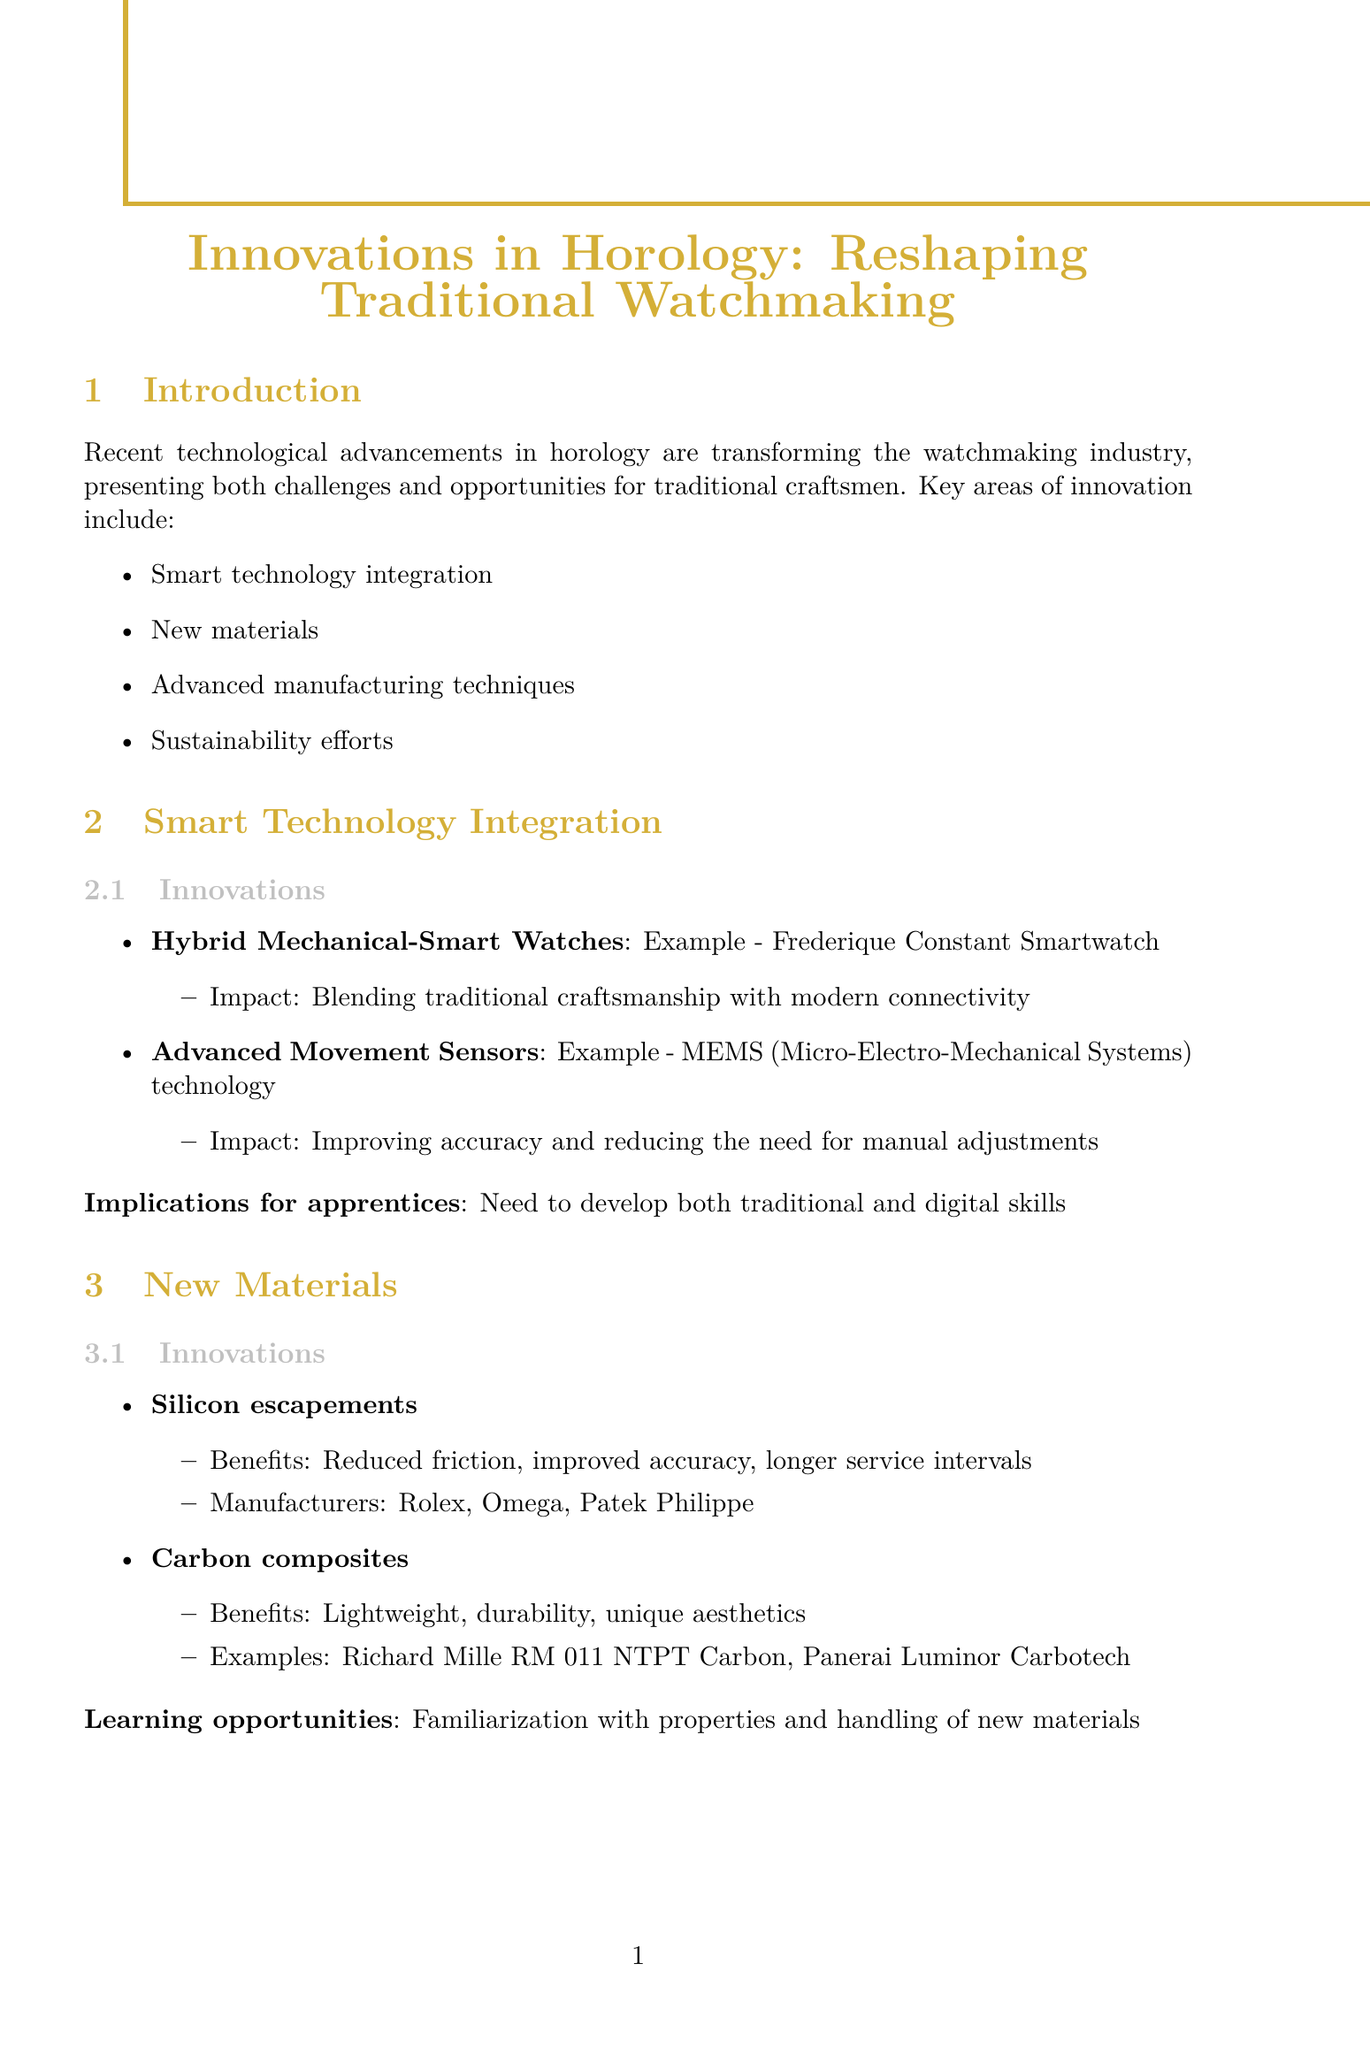What is the report title? The report title is stated at the beginning of the document.
Answer: Innovations in Horology: Reshaping Traditional Watchmaking What is a key area of innovation mentioned? The document lists key areas of innovation in horology.
Answer: Smart technology integration Which watch brand is mentioned for using silicon escapements? The document provides information on manufacturers using new materials.
Answer: Rolex What is an example of a solar-powered movement? The report gives specific examples under sustainability efforts.
Answer: Citizen Eco-Drive technology What challenge do traditional craftsmen face according to the report? The document outlines challenges faced by traditional methods.
Answer: Adapting centuries-old techniques to modern innovations Name a benefit of carbon composites as mentioned in the document. The benefits of new materials are highlighted in the document.
Answer: Lightweight Which case study discusses a luxury smartwatch? The document provides case studies on innovative products.
Answer: TAG Heuer Connected Calibre E4 What does the report suggest is crucial for future watchmakers? The conclusion emphasizes the key takeaways for future watchmakers.
Answer: Continuous learning and adaptability What manufacturing technique is associated with precision and efficiency? The innovations in advanced manufacturing techniques include specific methods.
Answer: CNC machining 